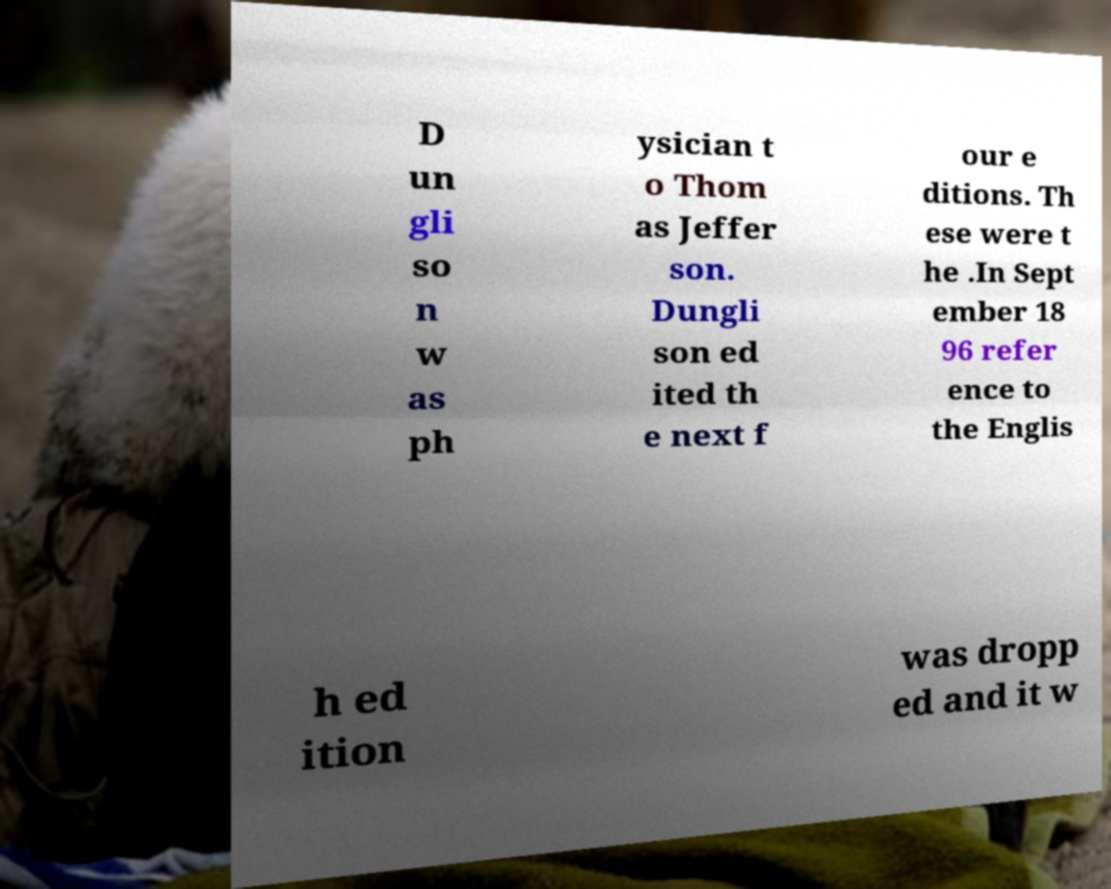Could you extract and type out the text from this image? D un gli so n w as ph ysician t o Thom as Jeffer son. Dungli son ed ited th e next f our e ditions. Th ese were t he .In Sept ember 18 96 refer ence to the Englis h ed ition was dropp ed and it w 